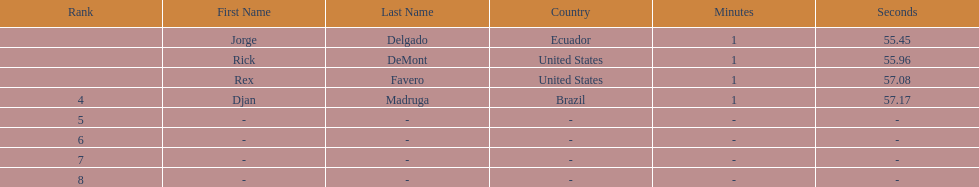What is the average time? 1:56.42. 